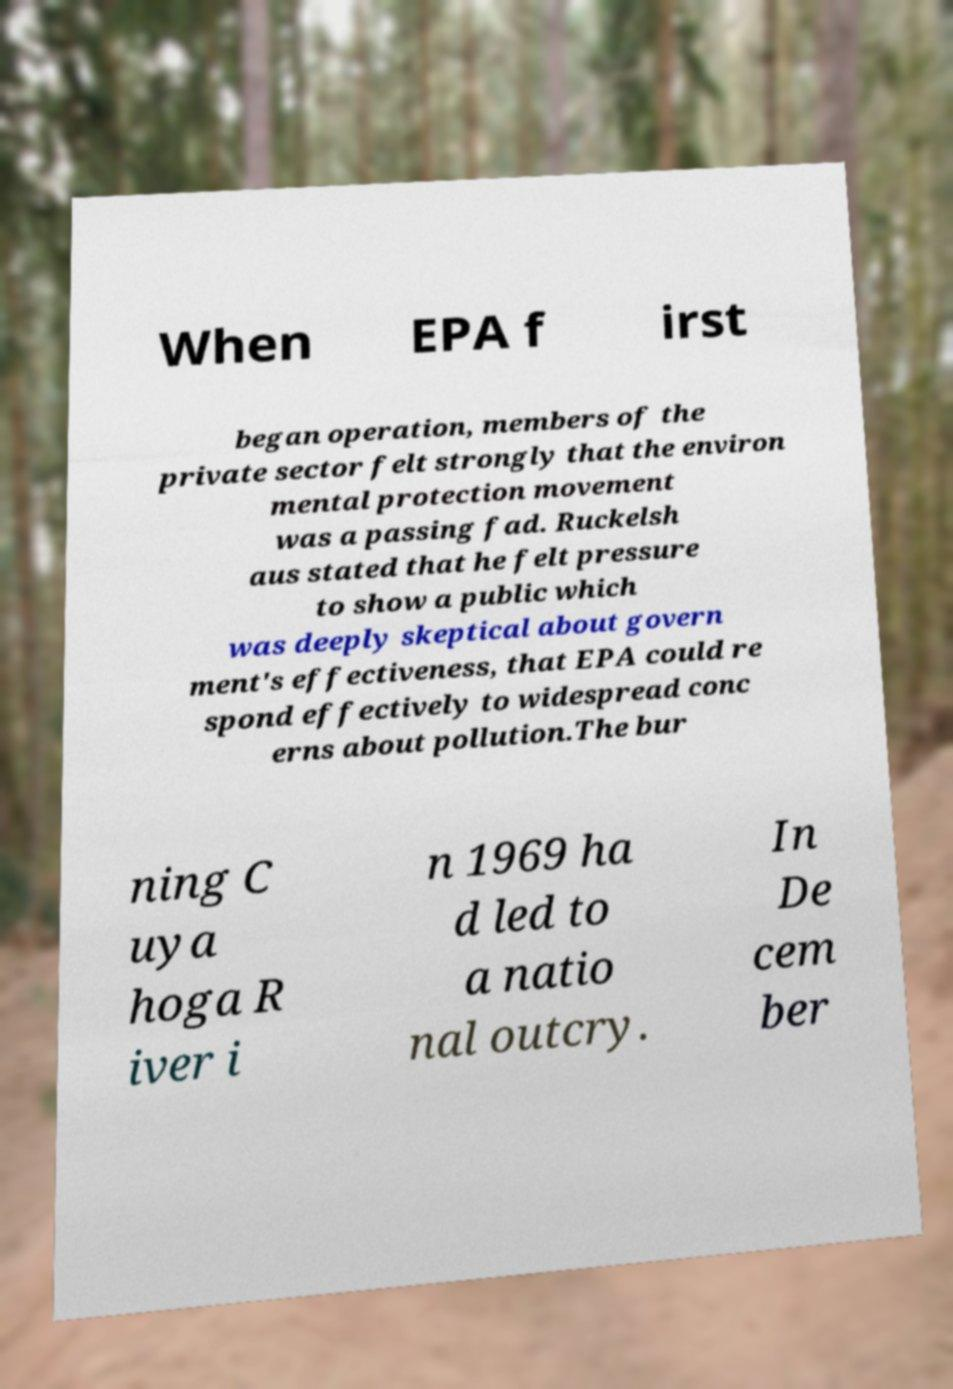Could you extract and type out the text from this image? When EPA f irst began operation, members of the private sector felt strongly that the environ mental protection movement was a passing fad. Ruckelsh aus stated that he felt pressure to show a public which was deeply skeptical about govern ment's effectiveness, that EPA could re spond effectively to widespread conc erns about pollution.The bur ning C uya hoga R iver i n 1969 ha d led to a natio nal outcry. In De cem ber 